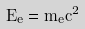Convert formula to latex. <formula><loc_0><loc_0><loc_500><loc_500>E _ { e } = m _ { e } c ^ { 2 }</formula> 